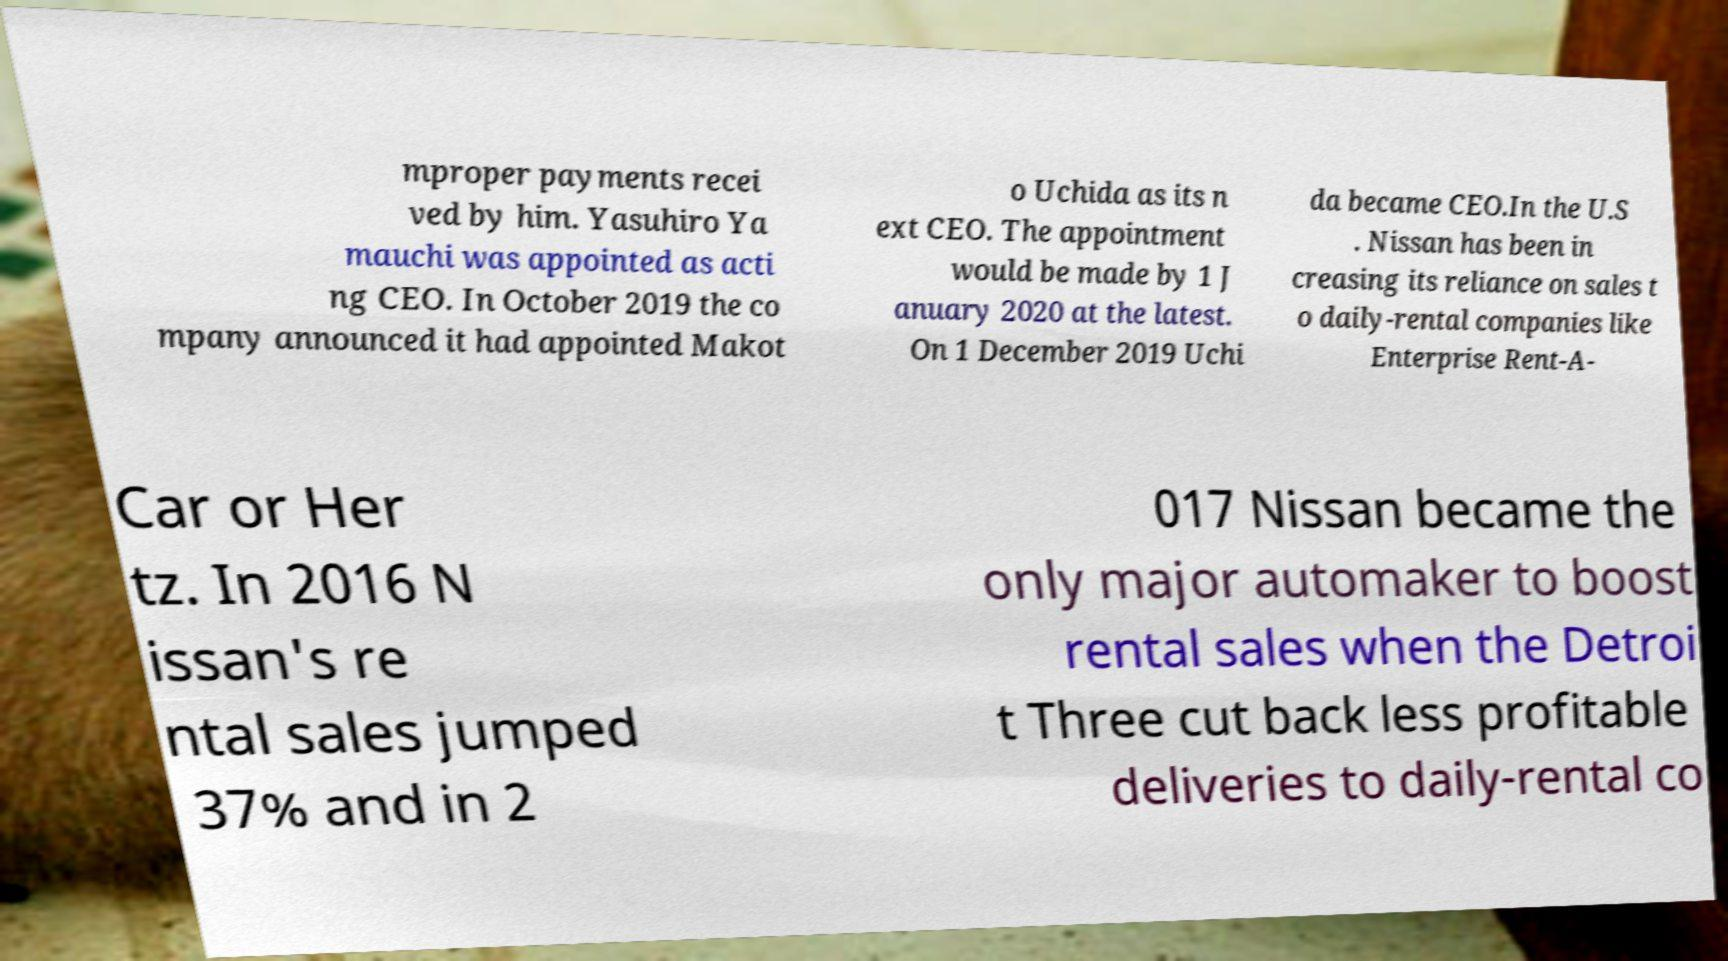Please identify and transcribe the text found in this image. mproper payments recei ved by him. Yasuhiro Ya mauchi was appointed as acti ng CEO. In October 2019 the co mpany announced it had appointed Makot o Uchida as its n ext CEO. The appointment would be made by 1 J anuary 2020 at the latest. On 1 December 2019 Uchi da became CEO.In the U.S . Nissan has been in creasing its reliance on sales t o daily-rental companies like Enterprise Rent-A- Car or Her tz. In 2016 N issan's re ntal sales jumped 37% and in 2 017 Nissan became the only major automaker to boost rental sales when the Detroi t Three cut back less profitable deliveries to daily-rental co 